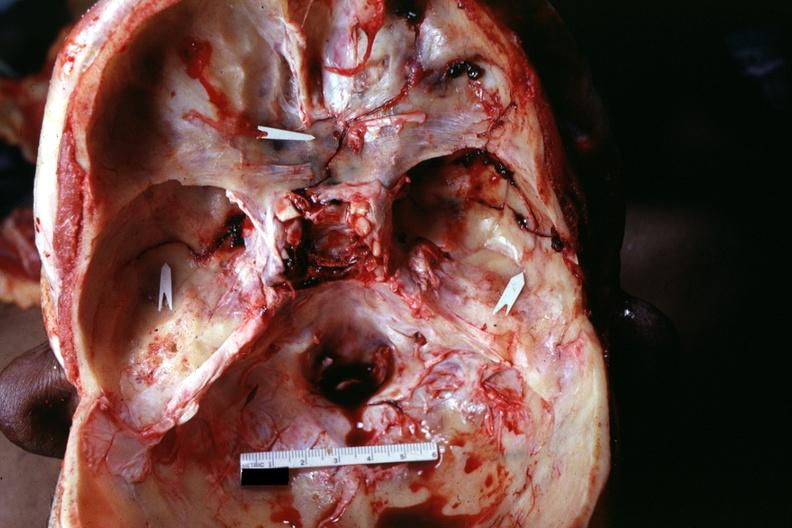what is present?
Answer the question using a single word or phrase. Bone, calvarium 